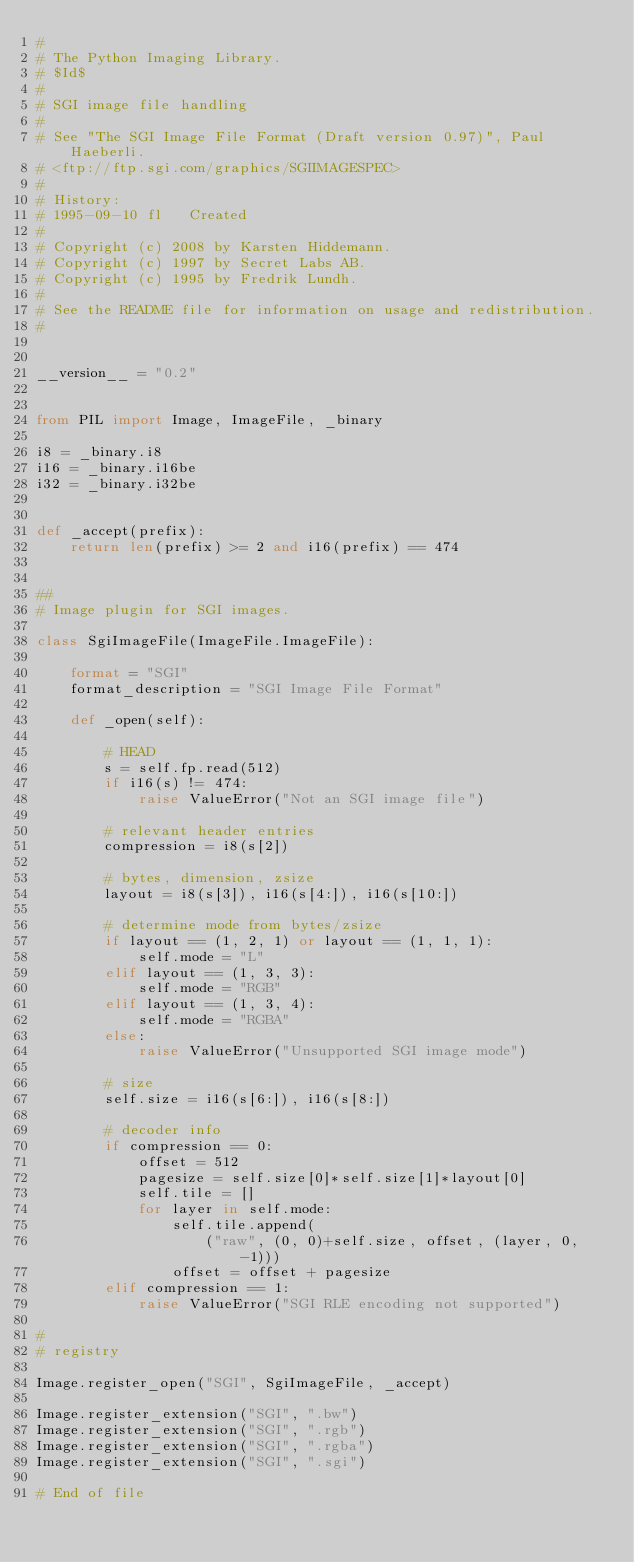<code> <loc_0><loc_0><loc_500><loc_500><_Python_>#
# The Python Imaging Library.
# $Id$
#
# SGI image file handling
#
# See "The SGI Image File Format (Draft version 0.97)", Paul Haeberli.
# <ftp://ftp.sgi.com/graphics/SGIIMAGESPEC>
#
# History:
# 1995-09-10 fl   Created
#
# Copyright (c) 2008 by Karsten Hiddemann.
# Copyright (c) 1997 by Secret Labs AB.
# Copyright (c) 1995 by Fredrik Lundh.
#
# See the README file for information on usage and redistribution.
#


__version__ = "0.2"


from PIL import Image, ImageFile, _binary

i8 = _binary.i8
i16 = _binary.i16be
i32 = _binary.i32be


def _accept(prefix):
    return len(prefix) >= 2 and i16(prefix) == 474


##
# Image plugin for SGI images.

class SgiImageFile(ImageFile.ImageFile):

    format = "SGI"
    format_description = "SGI Image File Format"

    def _open(self):

        # HEAD
        s = self.fp.read(512)
        if i16(s) != 474:
            raise ValueError("Not an SGI image file")

        # relevant header entries
        compression = i8(s[2])

        # bytes, dimension, zsize
        layout = i8(s[3]), i16(s[4:]), i16(s[10:])

        # determine mode from bytes/zsize
        if layout == (1, 2, 1) or layout == (1, 1, 1):
            self.mode = "L"
        elif layout == (1, 3, 3):
            self.mode = "RGB"
        elif layout == (1, 3, 4):
            self.mode = "RGBA"
        else:
            raise ValueError("Unsupported SGI image mode")

        # size
        self.size = i16(s[6:]), i16(s[8:])

        # decoder info
        if compression == 0:
            offset = 512
            pagesize = self.size[0]*self.size[1]*layout[0]
            self.tile = []
            for layer in self.mode:
                self.tile.append(
                    ("raw", (0, 0)+self.size, offset, (layer, 0, -1)))
                offset = offset + pagesize
        elif compression == 1:
            raise ValueError("SGI RLE encoding not supported")

#
# registry

Image.register_open("SGI", SgiImageFile, _accept)

Image.register_extension("SGI", ".bw")
Image.register_extension("SGI", ".rgb")
Image.register_extension("SGI", ".rgba")
Image.register_extension("SGI", ".sgi")

# End of file
</code> 